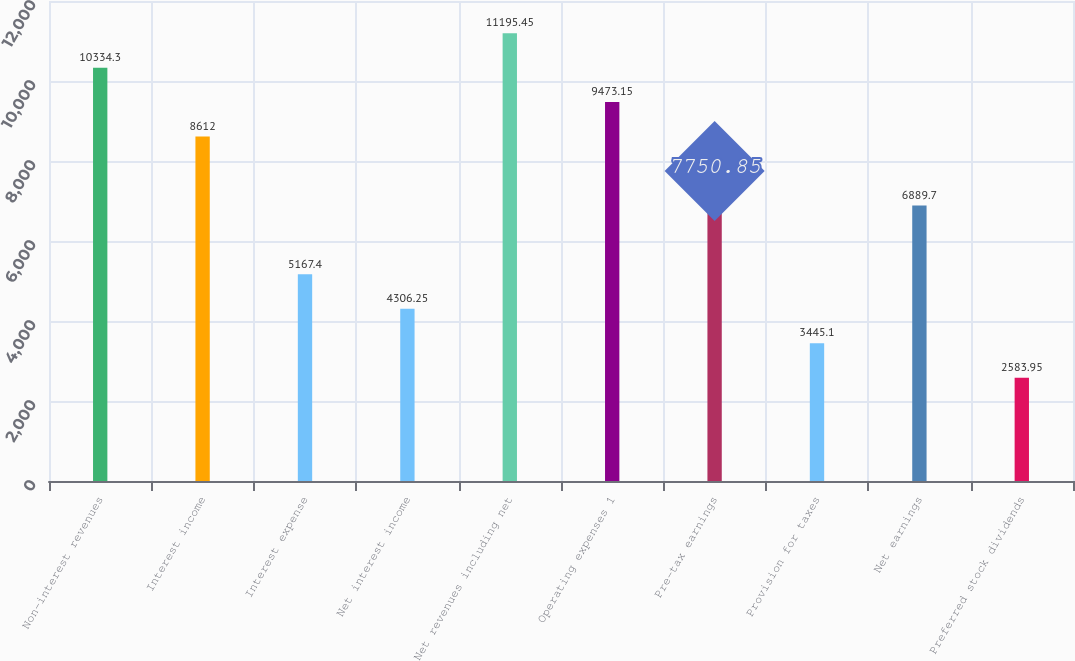<chart> <loc_0><loc_0><loc_500><loc_500><bar_chart><fcel>Non-interest revenues<fcel>Interest income<fcel>Interest expense<fcel>Net interest income<fcel>Net revenues including net<fcel>Operating expenses 1<fcel>Pre-tax earnings<fcel>Provision for taxes<fcel>Net earnings<fcel>Preferred stock dividends<nl><fcel>10334.3<fcel>8612<fcel>5167.4<fcel>4306.25<fcel>11195.5<fcel>9473.15<fcel>7750.85<fcel>3445.1<fcel>6889.7<fcel>2583.95<nl></chart> 